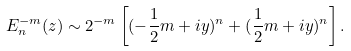<formula> <loc_0><loc_0><loc_500><loc_500>E _ { n } ^ { - m } ( z ) \sim 2 ^ { - m } \left [ ( - \frac { 1 } { 2 } m + i y ) ^ { n } + ( \frac { 1 } { 2 } m + i y ) ^ { n } \right ] .</formula> 